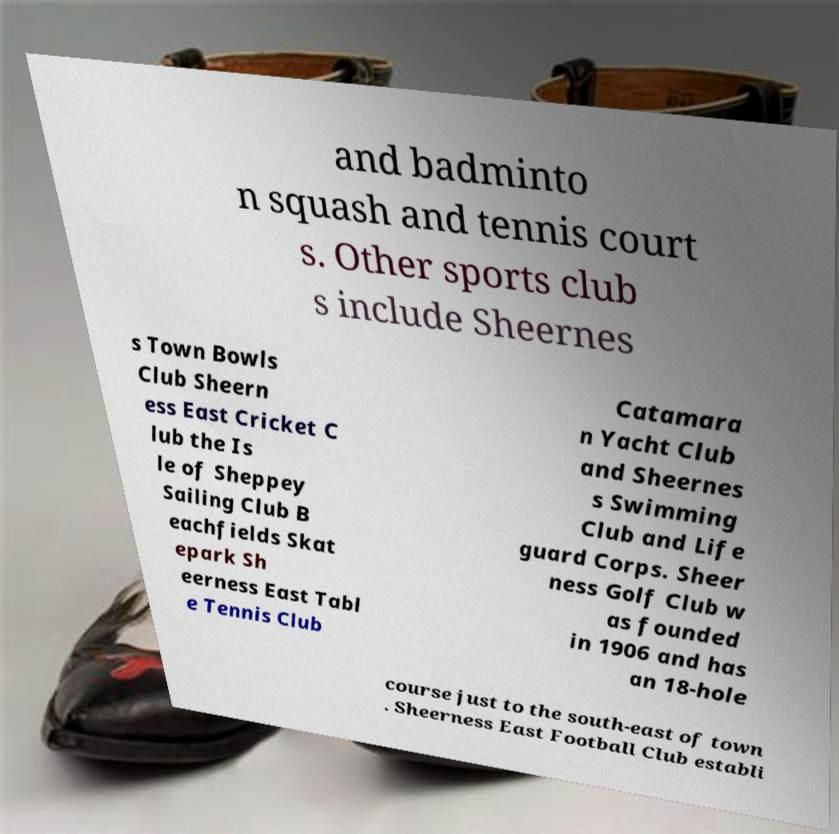Could you assist in decoding the text presented in this image and type it out clearly? and badminto n squash and tennis court s. Other sports club s include Sheernes s Town Bowls Club Sheern ess East Cricket C lub the Is le of Sheppey Sailing Club B eachfields Skat epark Sh eerness East Tabl e Tennis Club Catamara n Yacht Club and Sheernes s Swimming Club and Life guard Corps. Sheer ness Golf Club w as founded in 1906 and has an 18-hole course just to the south-east of town . Sheerness East Football Club establi 